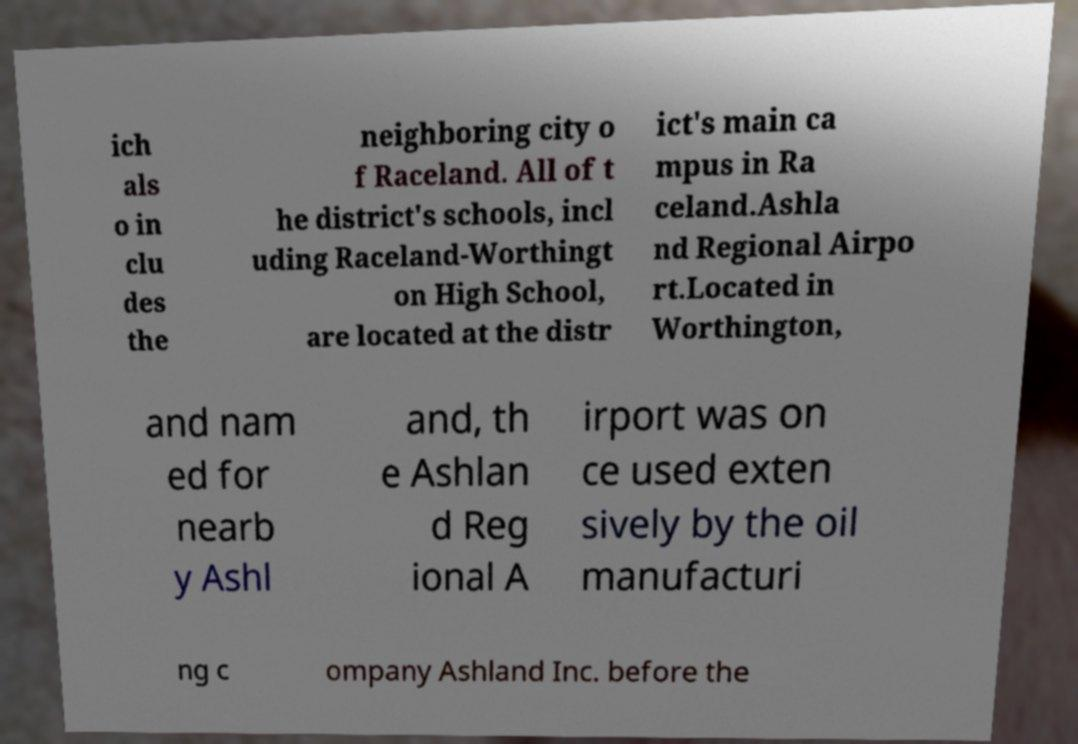I need the written content from this picture converted into text. Can you do that? ich als o in clu des the neighboring city o f Raceland. All of t he district's schools, incl uding Raceland-Worthingt on High School, are located at the distr ict's main ca mpus in Ra celand.Ashla nd Regional Airpo rt.Located in Worthington, and nam ed for nearb y Ashl and, th e Ashlan d Reg ional A irport was on ce used exten sively by the oil manufacturi ng c ompany Ashland Inc. before the 